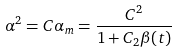<formula> <loc_0><loc_0><loc_500><loc_500>\alpha ^ { 2 } = C \alpha _ { m } = \frac { C ^ { 2 } } { 1 + C _ { 2 } \beta ( t ) }</formula> 